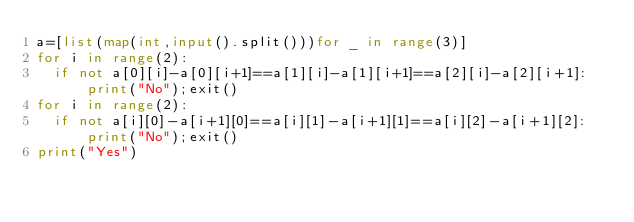<code> <loc_0><loc_0><loc_500><loc_500><_Python_>a=[list(map(int,input().split()))for _ in range(3)]
for i in range(2):
  if not a[0][i]-a[0][i+1]==a[1][i]-a[1][i+1]==a[2][i]-a[2][i+1]:print("No");exit()
for i in range(2):
  if not a[i][0]-a[i+1][0]==a[i][1]-a[i+1][1]==a[i][2]-a[i+1][2]:print("No");exit()
print("Yes")</code> 